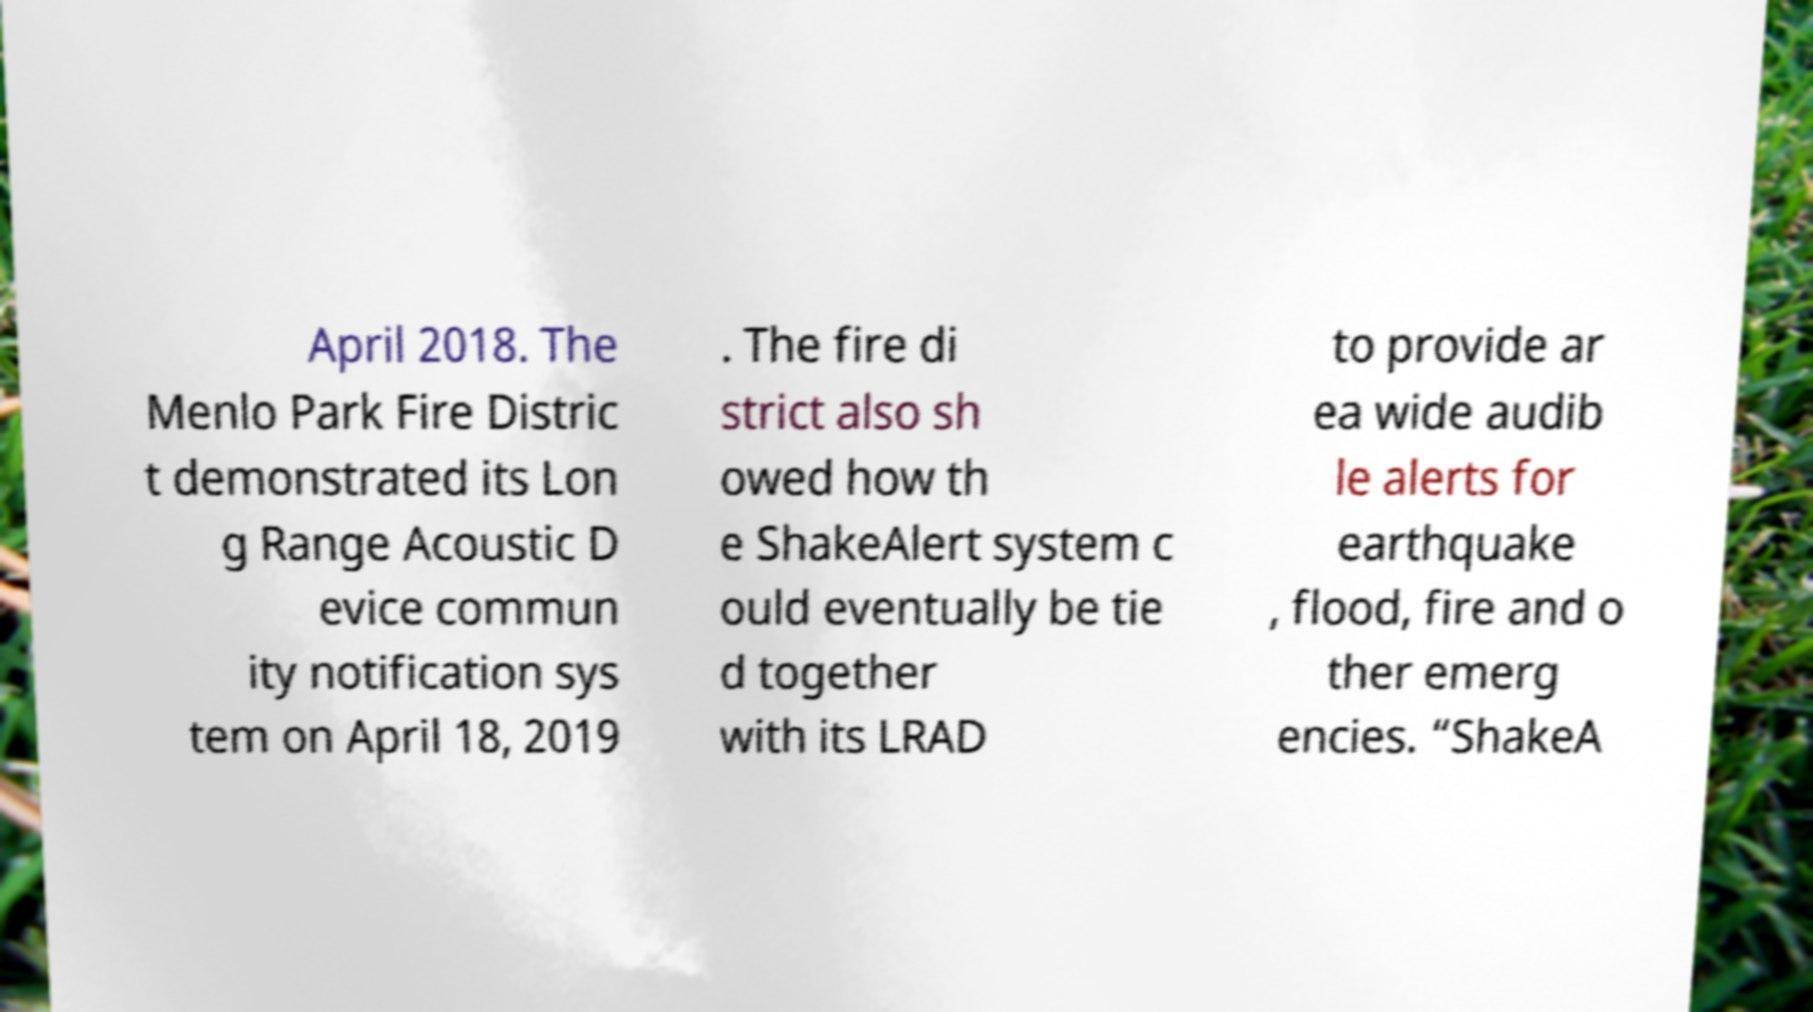I need the written content from this picture converted into text. Can you do that? April 2018. The Menlo Park Fire Distric t demonstrated its Lon g Range Acoustic D evice commun ity notification sys tem on April 18, 2019 . The fire di strict also sh owed how th e ShakeAlert system c ould eventually be tie d together with its LRAD to provide ar ea wide audib le alerts for earthquake , flood, fire and o ther emerg encies. “ShakeA 